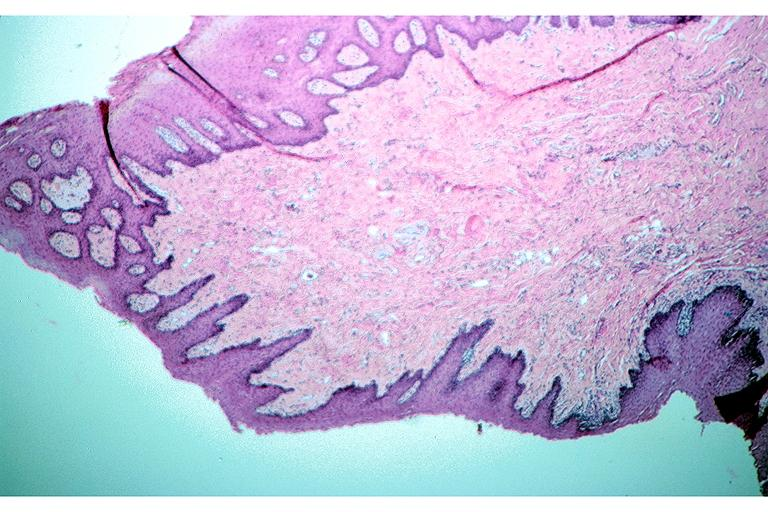s oral present?
Answer the question using a single word or phrase. Yes 